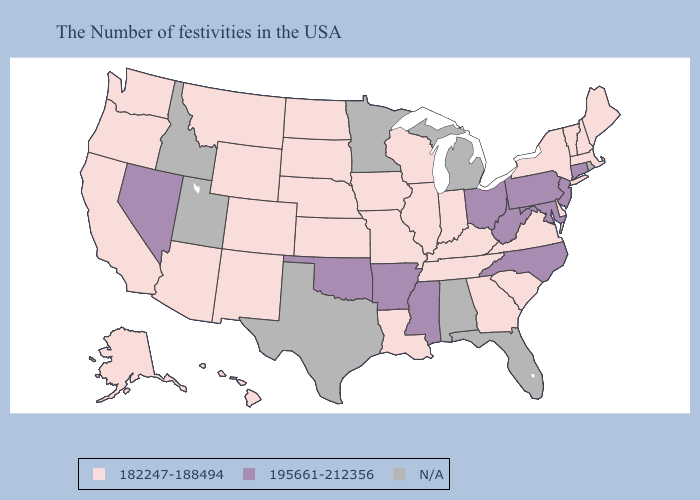Does Maine have the highest value in the USA?
Short answer required. No. Among the states that border Alabama , does Tennessee have the highest value?
Give a very brief answer. No. Name the states that have a value in the range N/A?
Be succinct. Rhode Island, Florida, Michigan, Alabama, Minnesota, Texas, Utah, Idaho. What is the highest value in the South ?
Be succinct. 195661-212356. Which states hav the highest value in the South?
Concise answer only. Maryland, North Carolina, West Virginia, Mississippi, Arkansas, Oklahoma. How many symbols are there in the legend?
Short answer required. 3. What is the highest value in states that border Nebraska?
Give a very brief answer. 182247-188494. Does Georgia have the highest value in the USA?
Concise answer only. No. Name the states that have a value in the range 195661-212356?
Quick response, please. Connecticut, New Jersey, Maryland, Pennsylvania, North Carolina, West Virginia, Ohio, Mississippi, Arkansas, Oklahoma, Nevada. Name the states that have a value in the range 182247-188494?
Be succinct. Maine, Massachusetts, New Hampshire, Vermont, New York, Delaware, Virginia, South Carolina, Georgia, Kentucky, Indiana, Tennessee, Wisconsin, Illinois, Louisiana, Missouri, Iowa, Kansas, Nebraska, South Dakota, North Dakota, Wyoming, Colorado, New Mexico, Montana, Arizona, California, Washington, Oregon, Alaska, Hawaii. Among the states that border West Virginia , does Kentucky have the lowest value?
Keep it brief. Yes. What is the lowest value in states that border New Jersey?
Write a very short answer. 182247-188494. What is the value of Vermont?
Quick response, please. 182247-188494. Does the map have missing data?
Answer briefly. Yes. 